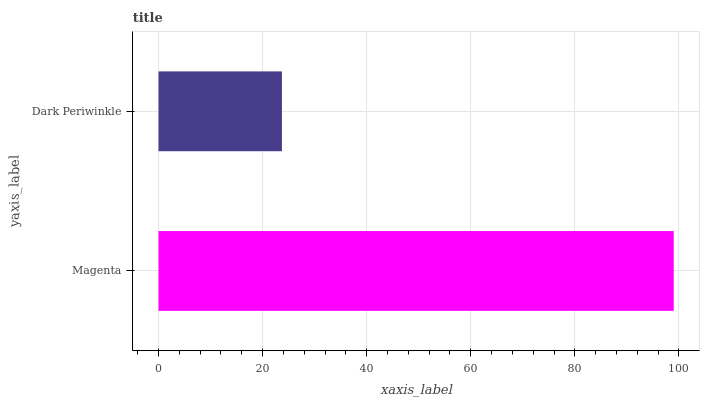Is Dark Periwinkle the minimum?
Answer yes or no. Yes. Is Magenta the maximum?
Answer yes or no. Yes. Is Dark Periwinkle the maximum?
Answer yes or no. No. Is Magenta greater than Dark Periwinkle?
Answer yes or no. Yes. Is Dark Periwinkle less than Magenta?
Answer yes or no. Yes. Is Dark Periwinkle greater than Magenta?
Answer yes or no. No. Is Magenta less than Dark Periwinkle?
Answer yes or no. No. Is Magenta the high median?
Answer yes or no. Yes. Is Dark Periwinkle the low median?
Answer yes or no. Yes. Is Dark Periwinkle the high median?
Answer yes or no. No. Is Magenta the low median?
Answer yes or no. No. 